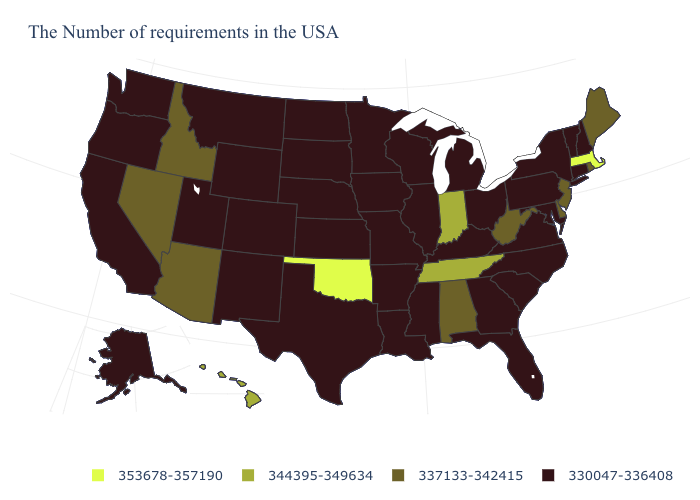Among the states that border North Carolina , which have the highest value?
Quick response, please. Tennessee. Is the legend a continuous bar?
Short answer required. No. What is the lowest value in the USA?
Be succinct. 330047-336408. What is the value of Idaho?
Answer briefly. 337133-342415. What is the highest value in states that border Maine?
Short answer required. 330047-336408. What is the value of South Carolina?
Quick response, please. 330047-336408. Is the legend a continuous bar?
Short answer required. No. Does the map have missing data?
Concise answer only. No. What is the value of Arkansas?
Short answer required. 330047-336408. What is the highest value in the USA?
Quick response, please. 353678-357190. Is the legend a continuous bar?
Concise answer only. No. What is the lowest value in the USA?
Short answer required. 330047-336408. Which states have the highest value in the USA?
Write a very short answer. Massachusetts, Oklahoma. Which states have the highest value in the USA?
Concise answer only. Massachusetts, Oklahoma. Name the states that have a value in the range 330047-336408?
Keep it brief. New Hampshire, Vermont, Connecticut, New York, Maryland, Pennsylvania, Virginia, North Carolina, South Carolina, Ohio, Florida, Georgia, Michigan, Kentucky, Wisconsin, Illinois, Mississippi, Louisiana, Missouri, Arkansas, Minnesota, Iowa, Kansas, Nebraska, Texas, South Dakota, North Dakota, Wyoming, Colorado, New Mexico, Utah, Montana, California, Washington, Oregon, Alaska. 